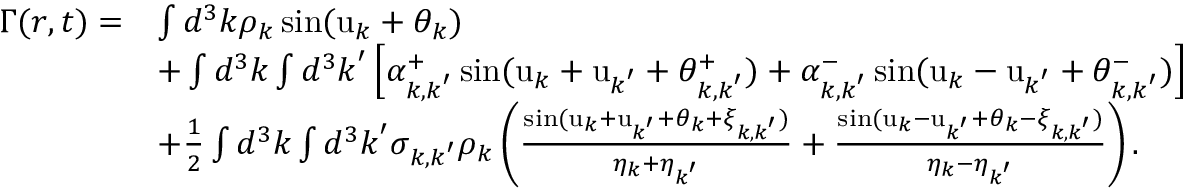Convert formula to latex. <formula><loc_0><loc_0><loc_500><loc_500>\begin{array} { r l } { \Gamma ( r , t ) = } & { \int d ^ { 3 } k \rho _ { k } \sin ( u _ { k } + \theta _ { k } ) } \\ & { + \int d ^ { 3 } k \int d ^ { 3 } k ^ { \prime } \left [ \alpha _ { k , k ^ { \prime } } ^ { + } \sin ( u _ { k } + u _ { k ^ { \prime } } + \theta _ { k , k ^ { \prime } } ^ { + } ) + \alpha _ { k , k ^ { \prime } } ^ { - } \sin ( u _ { k } - u _ { k ^ { \prime } } + \theta _ { k , k ^ { \prime } } ^ { - } ) \right ] } \\ & { + \frac { 1 } { 2 } \int d ^ { 3 } k \int d ^ { 3 } k ^ { \prime } \sigma _ { k , k ^ { \prime } } \rho _ { k } \left ( \frac { \sin ( u _ { k } + u _ { k ^ { \prime } } + \theta _ { k } + \xi _ { k , k ^ { \prime } } ) } { \eta _ { k } + \eta _ { k ^ { \prime } } } + \frac { \sin ( u _ { k } - u _ { k ^ { \prime } } + \theta _ { k } - \xi _ { k , k ^ { \prime } } ) } { \eta _ { k } - \eta _ { k ^ { \prime } } } \right ) . } \end{array}</formula> 